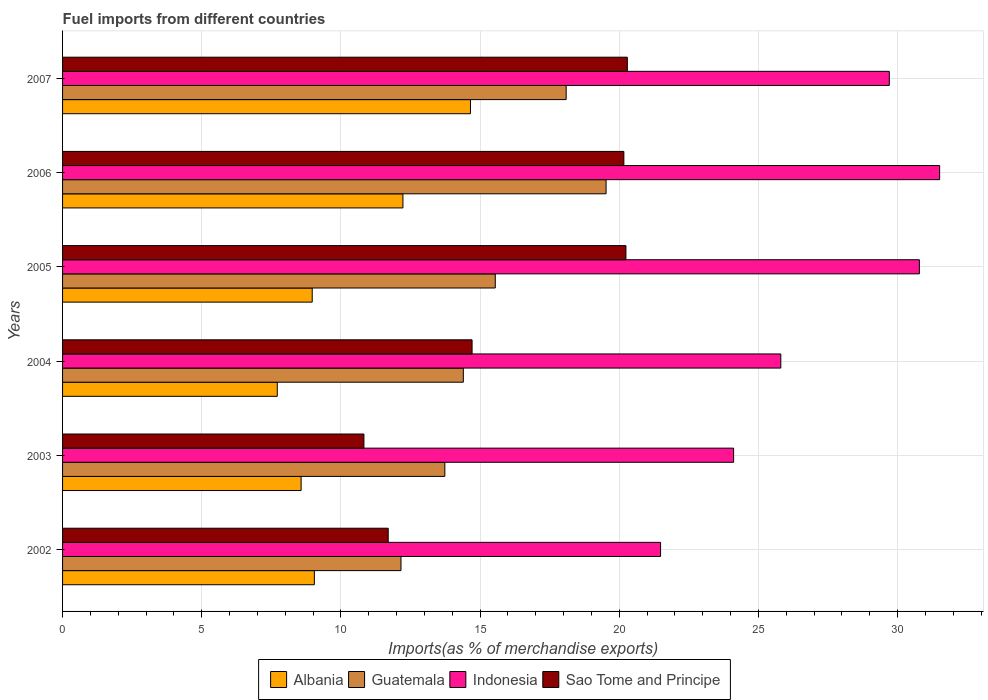How many different coloured bars are there?
Ensure brevity in your answer.  4. How many groups of bars are there?
Your response must be concise. 6. What is the label of the 6th group of bars from the top?
Offer a terse response. 2002. In how many cases, is the number of bars for a given year not equal to the number of legend labels?
Keep it short and to the point. 0. What is the percentage of imports to different countries in Indonesia in 2007?
Keep it short and to the point. 29.7. Across all years, what is the maximum percentage of imports to different countries in Albania?
Your response must be concise. 14.66. Across all years, what is the minimum percentage of imports to different countries in Guatemala?
Your answer should be very brief. 12.16. In which year was the percentage of imports to different countries in Indonesia maximum?
Provide a succinct answer. 2006. In which year was the percentage of imports to different countries in Sao Tome and Principe minimum?
Make the answer very short. 2003. What is the total percentage of imports to different countries in Guatemala in the graph?
Ensure brevity in your answer.  93.46. What is the difference between the percentage of imports to different countries in Guatemala in 2003 and that in 2007?
Ensure brevity in your answer.  -4.36. What is the difference between the percentage of imports to different countries in Sao Tome and Principe in 2005 and the percentage of imports to different countries in Albania in 2003?
Your answer should be compact. 11.67. What is the average percentage of imports to different countries in Albania per year?
Your answer should be very brief. 10.2. In the year 2002, what is the difference between the percentage of imports to different countries in Albania and percentage of imports to different countries in Sao Tome and Principe?
Your answer should be very brief. -2.65. What is the ratio of the percentage of imports to different countries in Guatemala in 2002 to that in 2003?
Provide a succinct answer. 0.89. Is the percentage of imports to different countries in Indonesia in 2002 less than that in 2005?
Keep it short and to the point. Yes. What is the difference between the highest and the second highest percentage of imports to different countries in Guatemala?
Your response must be concise. 1.43. What is the difference between the highest and the lowest percentage of imports to different countries in Albania?
Provide a succinct answer. 6.94. In how many years, is the percentage of imports to different countries in Guatemala greater than the average percentage of imports to different countries in Guatemala taken over all years?
Your response must be concise. 2. Is the sum of the percentage of imports to different countries in Albania in 2004 and 2005 greater than the maximum percentage of imports to different countries in Guatemala across all years?
Offer a very short reply. No. Is it the case that in every year, the sum of the percentage of imports to different countries in Sao Tome and Principe and percentage of imports to different countries in Guatemala is greater than the sum of percentage of imports to different countries in Indonesia and percentage of imports to different countries in Albania?
Ensure brevity in your answer.  No. What does the 1st bar from the top in 2002 represents?
Ensure brevity in your answer.  Sao Tome and Principe. What does the 1st bar from the bottom in 2007 represents?
Give a very brief answer. Albania. Is it the case that in every year, the sum of the percentage of imports to different countries in Sao Tome and Principe and percentage of imports to different countries in Indonesia is greater than the percentage of imports to different countries in Albania?
Make the answer very short. Yes. How many bars are there?
Keep it short and to the point. 24. How many years are there in the graph?
Offer a very short reply. 6. Are the values on the major ticks of X-axis written in scientific E-notation?
Offer a very short reply. No. Does the graph contain grids?
Provide a succinct answer. Yes. How many legend labels are there?
Your response must be concise. 4. What is the title of the graph?
Offer a terse response. Fuel imports from different countries. Does "Tunisia" appear as one of the legend labels in the graph?
Ensure brevity in your answer.  No. What is the label or title of the X-axis?
Make the answer very short. Imports(as % of merchandise exports). What is the label or title of the Y-axis?
Provide a short and direct response. Years. What is the Imports(as % of merchandise exports) in Albania in 2002?
Offer a terse response. 9.05. What is the Imports(as % of merchandise exports) of Guatemala in 2002?
Provide a succinct answer. 12.16. What is the Imports(as % of merchandise exports) of Indonesia in 2002?
Your response must be concise. 21.48. What is the Imports(as % of merchandise exports) in Sao Tome and Principe in 2002?
Make the answer very short. 11.7. What is the Imports(as % of merchandise exports) in Albania in 2003?
Provide a succinct answer. 8.57. What is the Imports(as % of merchandise exports) in Guatemala in 2003?
Offer a terse response. 13.73. What is the Imports(as % of merchandise exports) in Indonesia in 2003?
Ensure brevity in your answer.  24.11. What is the Imports(as % of merchandise exports) of Sao Tome and Principe in 2003?
Your answer should be very brief. 10.83. What is the Imports(as % of merchandise exports) in Albania in 2004?
Your answer should be very brief. 7.71. What is the Imports(as % of merchandise exports) of Guatemala in 2004?
Offer a very short reply. 14.4. What is the Imports(as % of merchandise exports) in Indonesia in 2004?
Ensure brevity in your answer.  25.8. What is the Imports(as % of merchandise exports) in Sao Tome and Principe in 2004?
Give a very brief answer. 14.71. What is the Imports(as % of merchandise exports) of Albania in 2005?
Ensure brevity in your answer.  8.97. What is the Imports(as % of merchandise exports) of Guatemala in 2005?
Ensure brevity in your answer.  15.55. What is the Imports(as % of merchandise exports) of Indonesia in 2005?
Your response must be concise. 30.78. What is the Imports(as % of merchandise exports) of Sao Tome and Principe in 2005?
Give a very brief answer. 20.24. What is the Imports(as % of merchandise exports) of Albania in 2006?
Provide a succinct answer. 12.23. What is the Imports(as % of merchandise exports) in Guatemala in 2006?
Give a very brief answer. 19.53. What is the Imports(as % of merchandise exports) of Indonesia in 2006?
Keep it short and to the point. 31.51. What is the Imports(as % of merchandise exports) of Sao Tome and Principe in 2006?
Your response must be concise. 20.17. What is the Imports(as % of merchandise exports) of Albania in 2007?
Ensure brevity in your answer.  14.66. What is the Imports(as % of merchandise exports) in Guatemala in 2007?
Give a very brief answer. 18.09. What is the Imports(as % of merchandise exports) of Indonesia in 2007?
Offer a terse response. 29.7. What is the Imports(as % of merchandise exports) of Sao Tome and Principe in 2007?
Your answer should be compact. 20.29. Across all years, what is the maximum Imports(as % of merchandise exports) in Albania?
Give a very brief answer. 14.66. Across all years, what is the maximum Imports(as % of merchandise exports) in Guatemala?
Your answer should be compact. 19.53. Across all years, what is the maximum Imports(as % of merchandise exports) of Indonesia?
Your response must be concise. 31.51. Across all years, what is the maximum Imports(as % of merchandise exports) in Sao Tome and Principe?
Your answer should be very brief. 20.29. Across all years, what is the minimum Imports(as % of merchandise exports) in Albania?
Your answer should be very brief. 7.71. Across all years, what is the minimum Imports(as % of merchandise exports) of Guatemala?
Keep it short and to the point. 12.16. Across all years, what is the minimum Imports(as % of merchandise exports) in Indonesia?
Your answer should be very brief. 21.48. Across all years, what is the minimum Imports(as % of merchandise exports) in Sao Tome and Principe?
Offer a very short reply. 10.83. What is the total Imports(as % of merchandise exports) of Albania in the graph?
Offer a very short reply. 61.18. What is the total Imports(as % of merchandise exports) of Guatemala in the graph?
Offer a terse response. 93.46. What is the total Imports(as % of merchandise exports) in Indonesia in the graph?
Offer a very short reply. 163.4. What is the total Imports(as % of merchandise exports) in Sao Tome and Principe in the graph?
Provide a short and direct response. 97.94. What is the difference between the Imports(as % of merchandise exports) of Albania in 2002 and that in 2003?
Provide a succinct answer. 0.48. What is the difference between the Imports(as % of merchandise exports) of Guatemala in 2002 and that in 2003?
Offer a very short reply. -1.58. What is the difference between the Imports(as % of merchandise exports) of Indonesia in 2002 and that in 2003?
Your response must be concise. -2.62. What is the difference between the Imports(as % of merchandise exports) of Sao Tome and Principe in 2002 and that in 2003?
Give a very brief answer. 0.87. What is the difference between the Imports(as % of merchandise exports) of Albania in 2002 and that in 2004?
Give a very brief answer. 1.33. What is the difference between the Imports(as % of merchandise exports) of Guatemala in 2002 and that in 2004?
Provide a succinct answer. -2.24. What is the difference between the Imports(as % of merchandise exports) in Indonesia in 2002 and that in 2004?
Make the answer very short. -4.32. What is the difference between the Imports(as % of merchandise exports) in Sao Tome and Principe in 2002 and that in 2004?
Your response must be concise. -3.01. What is the difference between the Imports(as % of merchandise exports) of Albania in 2002 and that in 2005?
Your answer should be compact. 0.08. What is the difference between the Imports(as % of merchandise exports) in Guatemala in 2002 and that in 2005?
Provide a short and direct response. -3.39. What is the difference between the Imports(as % of merchandise exports) of Indonesia in 2002 and that in 2005?
Your response must be concise. -9.3. What is the difference between the Imports(as % of merchandise exports) of Sao Tome and Principe in 2002 and that in 2005?
Ensure brevity in your answer.  -8.54. What is the difference between the Imports(as % of merchandise exports) in Albania in 2002 and that in 2006?
Offer a terse response. -3.18. What is the difference between the Imports(as % of merchandise exports) in Guatemala in 2002 and that in 2006?
Keep it short and to the point. -7.37. What is the difference between the Imports(as % of merchandise exports) of Indonesia in 2002 and that in 2006?
Make the answer very short. -10.03. What is the difference between the Imports(as % of merchandise exports) in Sao Tome and Principe in 2002 and that in 2006?
Your answer should be compact. -8.47. What is the difference between the Imports(as % of merchandise exports) of Albania in 2002 and that in 2007?
Provide a succinct answer. -5.61. What is the difference between the Imports(as % of merchandise exports) of Guatemala in 2002 and that in 2007?
Your answer should be compact. -5.93. What is the difference between the Imports(as % of merchandise exports) of Indonesia in 2002 and that in 2007?
Provide a succinct answer. -8.22. What is the difference between the Imports(as % of merchandise exports) of Sao Tome and Principe in 2002 and that in 2007?
Your answer should be compact. -8.59. What is the difference between the Imports(as % of merchandise exports) in Albania in 2003 and that in 2004?
Ensure brevity in your answer.  0.86. What is the difference between the Imports(as % of merchandise exports) in Guatemala in 2003 and that in 2004?
Your answer should be very brief. -0.66. What is the difference between the Imports(as % of merchandise exports) of Indonesia in 2003 and that in 2004?
Provide a short and direct response. -1.7. What is the difference between the Imports(as % of merchandise exports) in Sao Tome and Principe in 2003 and that in 2004?
Provide a succinct answer. -3.89. What is the difference between the Imports(as % of merchandise exports) in Albania in 2003 and that in 2005?
Your answer should be very brief. -0.4. What is the difference between the Imports(as % of merchandise exports) in Guatemala in 2003 and that in 2005?
Your answer should be compact. -1.81. What is the difference between the Imports(as % of merchandise exports) in Indonesia in 2003 and that in 2005?
Offer a terse response. -6.67. What is the difference between the Imports(as % of merchandise exports) in Sao Tome and Principe in 2003 and that in 2005?
Make the answer very short. -9.41. What is the difference between the Imports(as % of merchandise exports) of Albania in 2003 and that in 2006?
Provide a succinct answer. -3.66. What is the difference between the Imports(as % of merchandise exports) in Guatemala in 2003 and that in 2006?
Your answer should be compact. -5.79. What is the difference between the Imports(as % of merchandise exports) of Indonesia in 2003 and that in 2006?
Ensure brevity in your answer.  -7.4. What is the difference between the Imports(as % of merchandise exports) in Sao Tome and Principe in 2003 and that in 2006?
Offer a terse response. -9.34. What is the difference between the Imports(as % of merchandise exports) of Albania in 2003 and that in 2007?
Your answer should be compact. -6.08. What is the difference between the Imports(as % of merchandise exports) in Guatemala in 2003 and that in 2007?
Provide a succinct answer. -4.36. What is the difference between the Imports(as % of merchandise exports) of Indonesia in 2003 and that in 2007?
Offer a very short reply. -5.59. What is the difference between the Imports(as % of merchandise exports) of Sao Tome and Principe in 2003 and that in 2007?
Offer a very short reply. -9.46. What is the difference between the Imports(as % of merchandise exports) in Albania in 2004 and that in 2005?
Provide a short and direct response. -1.25. What is the difference between the Imports(as % of merchandise exports) in Guatemala in 2004 and that in 2005?
Ensure brevity in your answer.  -1.15. What is the difference between the Imports(as % of merchandise exports) of Indonesia in 2004 and that in 2005?
Give a very brief answer. -4.98. What is the difference between the Imports(as % of merchandise exports) in Sao Tome and Principe in 2004 and that in 2005?
Your response must be concise. -5.53. What is the difference between the Imports(as % of merchandise exports) of Albania in 2004 and that in 2006?
Your response must be concise. -4.51. What is the difference between the Imports(as % of merchandise exports) of Guatemala in 2004 and that in 2006?
Ensure brevity in your answer.  -5.13. What is the difference between the Imports(as % of merchandise exports) of Indonesia in 2004 and that in 2006?
Your answer should be very brief. -5.71. What is the difference between the Imports(as % of merchandise exports) in Sao Tome and Principe in 2004 and that in 2006?
Give a very brief answer. -5.45. What is the difference between the Imports(as % of merchandise exports) in Albania in 2004 and that in 2007?
Offer a terse response. -6.94. What is the difference between the Imports(as % of merchandise exports) of Guatemala in 2004 and that in 2007?
Your answer should be very brief. -3.69. What is the difference between the Imports(as % of merchandise exports) in Indonesia in 2004 and that in 2007?
Offer a terse response. -3.9. What is the difference between the Imports(as % of merchandise exports) in Sao Tome and Principe in 2004 and that in 2007?
Offer a terse response. -5.58. What is the difference between the Imports(as % of merchandise exports) of Albania in 2005 and that in 2006?
Your answer should be very brief. -3.26. What is the difference between the Imports(as % of merchandise exports) of Guatemala in 2005 and that in 2006?
Your answer should be compact. -3.98. What is the difference between the Imports(as % of merchandise exports) of Indonesia in 2005 and that in 2006?
Your answer should be very brief. -0.73. What is the difference between the Imports(as % of merchandise exports) in Sao Tome and Principe in 2005 and that in 2006?
Your response must be concise. 0.07. What is the difference between the Imports(as % of merchandise exports) of Albania in 2005 and that in 2007?
Keep it short and to the point. -5.69. What is the difference between the Imports(as % of merchandise exports) in Guatemala in 2005 and that in 2007?
Offer a terse response. -2.55. What is the difference between the Imports(as % of merchandise exports) in Sao Tome and Principe in 2005 and that in 2007?
Ensure brevity in your answer.  -0.05. What is the difference between the Imports(as % of merchandise exports) in Albania in 2006 and that in 2007?
Provide a succinct answer. -2.43. What is the difference between the Imports(as % of merchandise exports) in Guatemala in 2006 and that in 2007?
Your response must be concise. 1.43. What is the difference between the Imports(as % of merchandise exports) of Indonesia in 2006 and that in 2007?
Your response must be concise. 1.81. What is the difference between the Imports(as % of merchandise exports) of Sao Tome and Principe in 2006 and that in 2007?
Your response must be concise. -0.12. What is the difference between the Imports(as % of merchandise exports) of Albania in 2002 and the Imports(as % of merchandise exports) of Guatemala in 2003?
Ensure brevity in your answer.  -4.69. What is the difference between the Imports(as % of merchandise exports) of Albania in 2002 and the Imports(as % of merchandise exports) of Indonesia in 2003?
Offer a terse response. -15.06. What is the difference between the Imports(as % of merchandise exports) in Albania in 2002 and the Imports(as % of merchandise exports) in Sao Tome and Principe in 2003?
Ensure brevity in your answer.  -1.78. What is the difference between the Imports(as % of merchandise exports) in Guatemala in 2002 and the Imports(as % of merchandise exports) in Indonesia in 2003?
Your answer should be compact. -11.95. What is the difference between the Imports(as % of merchandise exports) in Guatemala in 2002 and the Imports(as % of merchandise exports) in Sao Tome and Principe in 2003?
Your answer should be very brief. 1.33. What is the difference between the Imports(as % of merchandise exports) of Indonesia in 2002 and the Imports(as % of merchandise exports) of Sao Tome and Principe in 2003?
Provide a succinct answer. 10.66. What is the difference between the Imports(as % of merchandise exports) in Albania in 2002 and the Imports(as % of merchandise exports) in Guatemala in 2004?
Provide a succinct answer. -5.35. What is the difference between the Imports(as % of merchandise exports) in Albania in 2002 and the Imports(as % of merchandise exports) in Indonesia in 2004?
Ensure brevity in your answer.  -16.76. What is the difference between the Imports(as % of merchandise exports) in Albania in 2002 and the Imports(as % of merchandise exports) in Sao Tome and Principe in 2004?
Ensure brevity in your answer.  -5.67. What is the difference between the Imports(as % of merchandise exports) in Guatemala in 2002 and the Imports(as % of merchandise exports) in Indonesia in 2004?
Your response must be concise. -13.65. What is the difference between the Imports(as % of merchandise exports) of Guatemala in 2002 and the Imports(as % of merchandise exports) of Sao Tome and Principe in 2004?
Give a very brief answer. -2.55. What is the difference between the Imports(as % of merchandise exports) of Indonesia in 2002 and the Imports(as % of merchandise exports) of Sao Tome and Principe in 2004?
Keep it short and to the point. 6.77. What is the difference between the Imports(as % of merchandise exports) in Albania in 2002 and the Imports(as % of merchandise exports) in Guatemala in 2005?
Keep it short and to the point. -6.5. What is the difference between the Imports(as % of merchandise exports) in Albania in 2002 and the Imports(as % of merchandise exports) in Indonesia in 2005?
Provide a short and direct response. -21.74. What is the difference between the Imports(as % of merchandise exports) of Albania in 2002 and the Imports(as % of merchandise exports) of Sao Tome and Principe in 2005?
Ensure brevity in your answer.  -11.19. What is the difference between the Imports(as % of merchandise exports) in Guatemala in 2002 and the Imports(as % of merchandise exports) in Indonesia in 2005?
Ensure brevity in your answer.  -18.62. What is the difference between the Imports(as % of merchandise exports) of Guatemala in 2002 and the Imports(as % of merchandise exports) of Sao Tome and Principe in 2005?
Your response must be concise. -8.08. What is the difference between the Imports(as % of merchandise exports) of Indonesia in 2002 and the Imports(as % of merchandise exports) of Sao Tome and Principe in 2005?
Keep it short and to the point. 1.24. What is the difference between the Imports(as % of merchandise exports) in Albania in 2002 and the Imports(as % of merchandise exports) in Guatemala in 2006?
Provide a short and direct response. -10.48. What is the difference between the Imports(as % of merchandise exports) of Albania in 2002 and the Imports(as % of merchandise exports) of Indonesia in 2006?
Offer a very short reply. -22.46. What is the difference between the Imports(as % of merchandise exports) of Albania in 2002 and the Imports(as % of merchandise exports) of Sao Tome and Principe in 2006?
Provide a succinct answer. -11.12. What is the difference between the Imports(as % of merchandise exports) in Guatemala in 2002 and the Imports(as % of merchandise exports) in Indonesia in 2006?
Ensure brevity in your answer.  -19.35. What is the difference between the Imports(as % of merchandise exports) in Guatemala in 2002 and the Imports(as % of merchandise exports) in Sao Tome and Principe in 2006?
Provide a succinct answer. -8.01. What is the difference between the Imports(as % of merchandise exports) in Indonesia in 2002 and the Imports(as % of merchandise exports) in Sao Tome and Principe in 2006?
Make the answer very short. 1.32. What is the difference between the Imports(as % of merchandise exports) of Albania in 2002 and the Imports(as % of merchandise exports) of Guatemala in 2007?
Your answer should be very brief. -9.05. What is the difference between the Imports(as % of merchandise exports) in Albania in 2002 and the Imports(as % of merchandise exports) in Indonesia in 2007?
Your response must be concise. -20.66. What is the difference between the Imports(as % of merchandise exports) in Albania in 2002 and the Imports(as % of merchandise exports) in Sao Tome and Principe in 2007?
Make the answer very short. -11.24. What is the difference between the Imports(as % of merchandise exports) in Guatemala in 2002 and the Imports(as % of merchandise exports) in Indonesia in 2007?
Make the answer very short. -17.54. What is the difference between the Imports(as % of merchandise exports) of Guatemala in 2002 and the Imports(as % of merchandise exports) of Sao Tome and Principe in 2007?
Your answer should be very brief. -8.13. What is the difference between the Imports(as % of merchandise exports) in Indonesia in 2002 and the Imports(as % of merchandise exports) in Sao Tome and Principe in 2007?
Ensure brevity in your answer.  1.19. What is the difference between the Imports(as % of merchandise exports) of Albania in 2003 and the Imports(as % of merchandise exports) of Guatemala in 2004?
Keep it short and to the point. -5.83. What is the difference between the Imports(as % of merchandise exports) in Albania in 2003 and the Imports(as % of merchandise exports) in Indonesia in 2004?
Your response must be concise. -17.23. What is the difference between the Imports(as % of merchandise exports) of Albania in 2003 and the Imports(as % of merchandise exports) of Sao Tome and Principe in 2004?
Offer a very short reply. -6.14. What is the difference between the Imports(as % of merchandise exports) of Guatemala in 2003 and the Imports(as % of merchandise exports) of Indonesia in 2004?
Your answer should be very brief. -12.07. What is the difference between the Imports(as % of merchandise exports) in Guatemala in 2003 and the Imports(as % of merchandise exports) in Sao Tome and Principe in 2004?
Your answer should be compact. -0.98. What is the difference between the Imports(as % of merchandise exports) of Indonesia in 2003 and the Imports(as % of merchandise exports) of Sao Tome and Principe in 2004?
Provide a short and direct response. 9.4. What is the difference between the Imports(as % of merchandise exports) in Albania in 2003 and the Imports(as % of merchandise exports) in Guatemala in 2005?
Ensure brevity in your answer.  -6.98. What is the difference between the Imports(as % of merchandise exports) in Albania in 2003 and the Imports(as % of merchandise exports) in Indonesia in 2005?
Your response must be concise. -22.21. What is the difference between the Imports(as % of merchandise exports) of Albania in 2003 and the Imports(as % of merchandise exports) of Sao Tome and Principe in 2005?
Offer a terse response. -11.67. What is the difference between the Imports(as % of merchandise exports) of Guatemala in 2003 and the Imports(as % of merchandise exports) of Indonesia in 2005?
Provide a succinct answer. -17.05. What is the difference between the Imports(as % of merchandise exports) in Guatemala in 2003 and the Imports(as % of merchandise exports) in Sao Tome and Principe in 2005?
Your answer should be compact. -6.51. What is the difference between the Imports(as % of merchandise exports) of Indonesia in 2003 and the Imports(as % of merchandise exports) of Sao Tome and Principe in 2005?
Provide a short and direct response. 3.87. What is the difference between the Imports(as % of merchandise exports) in Albania in 2003 and the Imports(as % of merchandise exports) in Guatemala in 2006?
Provide a succinct answer. -10.96. What is the difference between the Imports(as % of merchandise exports) in Albania in 2003 and the Imports(as % of merchandise exports) in Indonesia in 2006?
Ensure brevity in your answer.  -22.94. What is the difference between the Imports(as % of merchandise exports) in Albania in 2003 and the Imports(as % of merchandise exports) in Sao Tome and Principe in 2006?
Provide a short and direct response. -11.6. What is the difference between the Imports(as % of merchandise exports) in Guatemala in 2003 and the Imports(as % of merchandise exports) in Indonesia in 2006?
Your response must be concise. -17.78. What is the difference between the Imports(as % of merchandise exports) of Guatemala in 2003 and the Imports(as % of merchandise exports) of Sao Tome and Principe in 2006?
Keep it short and to the point. -6.43. What is the difference between the Imports(as % of merchandise exports) in Indonesia in 2003 and the Imports(as % of merchandise exports) in Sao Tome and Principe in 2006?
Ensure brevity in your answer.  3.94. What is the difference between the Imports(as % of merchandise exports) in Albania in 2003 and the Imports(as % of merchandise exports) in Guatemala in 2007?
Your answer should be very brief. -9.52. What is the difference between the Imports(as % of merchandise exports) of Albania in 2003 and the Imports(as % of merchandise exports) of Indonesia in 2007?
Keep it short and to the point. -21.13. What is the difference between the Imports(as % of merchandise exports) of Albania in 2003 and the Imports(as % of merchandise exports) of Sao Tome and Principe in 2007?
Your answer should be very brief. -11.72. What is the difference between the Imports(as % of merchandise exports) in Guatemala in 2003 and the Imports(as % of merchandise exports) in Indonesia in 2007?
Your response must be concise. -15.97. What is the difference between the Imports(as % of merchandise exports) in Guatemala in 2003 and the Imports(as % of merchandise exports) in Sao Tome and Principe in 2007?
Your answer should be very brief. -6.56. What is the difference between the Imports(as % of merchandise exports) of Indonesia in 2003 and the Imports(as % of merchandise exports) of Sao Tome and Principe in 2007?
Your answer should be compact. 3.82. What is the difference between the Imports(as % of merchandise exports) of Albania in 2004 and the Imports(as % of merchandise exports) of Guatemala in 2005?
Your answer should be very brief. -7.83. What is the difference between the Imports(as % of merchandise exports) of Albania in 2004 and the Imports(as % of merchandise exports) of Indonesia in 2005?
Offer a very short reply. -23.07. What is the difference between the Imports(as % of merchandise exports) in Albania in 2004 and the Imports(as % of merchandise exports) in Sao Tome and Principe in 2005?
Offer a very short reply. -12.53. What is the difference between the Imports(as % of merchandise exports) of Guatemala in 2004 and the Imports(as % of merchandise exports) of Indonesia in 2005?
Offer a terse response. -16.38. What is the difference between the Imports(as % of merchandise exports) in Guatemala in 2004 and the Imports(as % of merchandise exports) in Sao Tome and Principe in 2005?
Your answer should be compact. -5.84. What is the difference between the Imports(as % of merchandise exports) in Indonesia in 2004 and the Imports(as % of merchandise exports) in Sao Tome and Principe in 2005?
Offer a terse response. 5.56. What is the difference between the Imports(as % of merchandise exports) of Albania in 2004 and the Imports(as % of merchandise exports) of Guatemala in 2006?
Your answer should be compact. -11.81. What is the difference between the Imports(as % of merchandise exports) of Albania in 2004 and the Imports(as % of merchandise exports) of Indonesia in 2006?
Give a very brief answer. -23.8. What is the difference between the Imports(as % of merchandise exports) in Albania in 2004 and the Imports(as % of merchandise exports) in Sao Tome and Principe in 2006?
Provide a succinct answer. -12.45. What is the difference between the Imports(as % of merchandise exports) of Guatemala in 2004 and the Imports(as % of merchandise exports) of Indonesia in 2006?
Your answer should be very brief. -17.11. What is the difference between the Imports(as % of merchandise exports) in Guatemala in 2004 and the Imports(as % of merchandise exports) in Sao Tome and Principe in 2006?
Give a very brief answer. -5.77. What is the difference between the Imports(as % of merchandise exports) in Indonesia in 2004 and the Imports(as % of merchandise exports) in Sao Tome and Principe in 2006?
Ensure brevity in your answer.  5.64. What is the difference between the Imports(as % of merchandise exports) of Albania in 2004 and the Imports(as % of merchandise exports) of Guatemala in 2007?
Make the answer very short. -10.38. What is the difference between the Imports(as % of merchandise exports) of Albania in 2004 and the Imports(as % of merchandise exports) of Indonesia in 2007?
Provide a short and direct response. -21.99. What is the difference between the Imports(as % of merchandise exports) of Albania in 2004 and the Imports(as % of merchandise exports) of Sao Tome and Principe in 2007?
Give a very brief answer. -12.58. What is the difference between the Imports(as % of merchandise exports) in Guatemala in 2004 and the Imports(as % of merchandise exports) in Indonesia in 2007?
Offer a terse response. -15.3. What is the difference between the Imports(as % of merchandise exports) in Guatemala in 2004 and the Imports(as % of merchandise exports) in Sao Tome and Principe in 2007?
Make the answer very short. -5.89. What is the difference between the Imports(as % of merchandise exports) of Indonesia in 2004 and the Imports(as % of merchandise exports) of Sao Tome and Principe in 2007?
Offer a terse response. 5.51. What is the difference between the Imports(as % of merchandise exports) of Albania in 2005 and the Imports(as % of merchandise exports) of Guatemala in 2006?
Give a very brief answer. -10.56. What is the difference between the Imports(as % of merchandise exports) of Albania in 2005 and the Imports(as % of merchandise exports) of Indonesia in 2006?
Offer a terse response. -22.54. What is the difference between the Imports(as % of merchandise exports) of Albania in 2005 and the Imports(as % of merchandise exports) of Sao Tome and Principe in 2006?
Your response must be concise. -11.2. What is the difference between the Imports(as % of merchandise exports) in Guatemala in 2005 and the Imports(as % of merchandise exports) in Indonesia in 2006?
Give a very brief answer. -15.96. What is the difference between the Imports(as % of merchandise exports) of Guatemala in 2005 and the Imports(as % of merchandise exports) of Sao Tome and Principe in 2006?
Your answer should be very brief. -4.62. What is the difference between the Imports(as % of merchandise exports) in Indonesia in 2005 and the Imports(as % of merchandise exports) in Sao Tome and Principe in 2006?
Your answer should be very brief. 10.62. What is the difference between the Imports(as % of merchandise exports) in Albania in 2005 and the Imports(as % of merchandise exports) in Guatemala in 2007?
Provide a short and direct response. -9.12. What is the difference between the Imports(as % of merchandise exports) in Albania in 2005 and the Imports(as % of merchandise exports) in Indonesia in 2007?
Your answer should be compact. -20.73. What is the difference between the Imports(as % of merchandise exports) in Albania in 2005 and the Imports(as % of merchandise exports) in Sao Tome and Principe in 2007?
Give a very brief answer. -11.32. What is the difference between the Imports(as % of merchandise exports) in Guatemala in 2005 and the Imports(as % of merchandise exports) in Indonesia in 2007?
Provide a short and direct response. -14.16. What is the difference between the Imports(as % of merchandise exports) of Guatemala in 2005 and the Imports(as % of merchandise exports) of Sao Tome and Principe in 2007?
Provide a succinct answer. -4.74. What is the difference between the Imports(as % of merchandise exports) in Indonesia in 2005 and the Imports(as % of merchandise exports) in Sao Tome and Principe in 2007?
Offer a terse response. 10.49. What is the difference between the Imports(as % of merchandise exports) of Albania in 2006 and the Imports(as % of merchandise exports) of Guatemala in 2007?
Provide a succinct answer. -5.86. What is the difference between the Imports(as % of merchandise exports) of Albania in 2006 and the Imports(as % of merchandise exports) of Indonesia in 2007?
Make the answer very short. -17.47. What is the difference between the Imports(as % of merchandise exports) of Albania in 2006 and the Imports(as % of merchandise exports) of Sao Tome and Principe in 2007?
Your response must be concise. -8.06. What is the difference between the Imports(as % of merchandise exports) in Guatemala in 2006 and the Imports(as % of merchandise exports) in Indonesia in 2007?
Keep it short and to the point. -10.18. What is the difference between the Imports(as % of merchandise exports) of Guatemala in 2006 and the Imports(as % of merchandise exports) of Sao Tome and Principe in 2007?
Your answer should be compact. -0.76. What is the difference between the Imports(as % of merchandise exports) in Indonesia in 2006 and the Imports(as % of merchandise exports) in Sao Tome and Principe in 2007?
Make the answer very short. 11.22. What is the average Imports(as % of merchandise exports) in Albania per year?
Provide a short and direct response. 10.2. What is the average Imports(as % of merchandise exports) in Guatemala per year?
Give a very brief answer. 15.58. What is the average Imports(as % of merchandise exports) of Indonesia per year?
Offer a very short reply. 27.23. What is the average Imports(as % of merchandise exports) of Sao Tome and Principe per year?
Your answer should be compact. 16.32. In the year 2002, what is the difference between the Imports(as % of merchandise exports) in Albania and Imports(as % of merchandise exports) in Guatemala?
Offer a terse response. -3.11. In the year 2002, what is the difference between the Imports(as % of merchandise exports) of Albania and Imports(as % of merchandise exports) of Indonesia?
Provide a succinct answer. -12.44. In the year 2002, what is the difference between the Imports(as % of merchandise exports) of Albania and Imports(as % of merchandise exports) of Sao Tome and Principe?
Offer a very short reply. -2.65. In the year 2002, what is the difference between the Imports(as % of merchandise exports) in Guatemala and Imports(as % of merchandise exports) in Indonesia?
Keep it short and to the point. -9.33. In the year 2002, what is the difference between the Imports(as % of merchandise exports) in Guatemala and Imports(as % of merchandise exports) in Sao Tome and Principe?
Give a very brief answer. 0.46. In the year 2002, what is the difference between the Imports(as % of merchandise exports) of Indonesia and Imports(as % of merchandise exports) of Sao Tome and Principe?
Keep it short and to the point. 9.79. In the year 2003, what is the difference between the Imports(as % of merchandise exports) of Albania and Imports(as % of merchandise exports) of Guatemala?
Offer a terse response. -5.16. In the year 2003, what is the difference between the Imports(as % of merchandise exports) in Albania and Imports(as % of merchandise exports) in Indonesia?
Offer a very short reply. -15.54. In the year 2003, what is the difference between the Imports(as % of merchandise exports) in Albania and Imports(as % of merchandise exports) in Sao Tome and Principe?
Provide a succinct answer. -2.26. In the year 2003, what is the difference between the Imports(as % of merchandise exports) in Guatemala and Imports(as % of merchandise exports) in Indonesia?
Your answer should be compact. -10.37. In the year 2003, what is the difference between the Imports(as % of merchandise exports) of Guatemala and Imports(as % of merchandise exports) of Sao Tome and Principe?
Your response must be concise. 2.91. In the year 2003, what is the difference between the Imports(as % of merchandise exports) of Indonesia and Imports(as % of merchandise exports) of Sao Tome and Principe?
Your answer should be compact. 13.28. In the year 2004, what is the difference between the Imports(as % of merchandise exports) of Albania and Imports(as % of merchandise exports) of Guatemala?
Offer a very short reply. -6.68. In the year 2004, what is the difference between the Imports(as % of merchandise exports) in Albania and Imports(as % of merchandise exports) in Indonesia?
Your response must be concise. -18.09. In the year 2004, what is the difference between the Imports(as % of merchandise exports) in Albania and Imports(as % of merchandise exports) in Sao Tome and Principe?
Make the answer very short. -7. In the year 2004, what is the difference between the Imports(as % of merchandise exports) in Guatemala and Imports(as % of merchandise exports) in Indonesia?
Provide a short and direct response. -11.41. In the year 2004, what is the difference between the Imports(as % of merchandise exports) of Guatemala and Imports(as % of merchandise exports) of Sao Tome and Principe?
Offer a very short reply. -0.31. In the year 2004, what is the difference between the Imports(as % of merchandise exports) of Indonesia and Imports(as % of merchandise exports) of Sao Tome and Principe?
Ensure brevity in your answer.  11.09. In the year 2005, what is the difference between the Imports(as % of merchandise exports) of Albania and Imports(as % of merchandise exports) of Guatemala?
Your answer should be very brief. -6.58. In the year 2005, what is the difference between the Imports(as % of merchandise exports) of Albania and Imports(as % of merchandise exports) of Indonesia?
Offer a very short reply. -21.81. In the year 2005, what is the difference between the Imports(as % of merchandise exports) in Albania and Imports(as % of merchandise exports) in Sao Tome and Principe?
Provide a succinct answer. -11.27. In the year 2005, what is the difference between the Imports(as % of merchandise exports) of Guatemala and Imports(as % of merchandise exports) of Indonesia?
Ensure brevity in your answer.  -15.24. In the year 2005, what is the difference between the Imports(as % of merchandise exports) in Guatemala and Imports(as % of merchandise exports) in Sao Tome and Principe?
Offer a terse response. -4.69. In the year 2005, what is the difference between the Imports(as % of merchandise exports) in Indonesia and Imports(as % of merchandise exports) in Sao Tome and Principe?
Your answer should be very brief. 10.54. In the year 2006, what is the difference between the Imports(as % of merchandise exports) of Albania and Imports(as % of merchandise exports) of Guatemala?
Your answer should be compact. -7.3. In the year 2006, what is the difference between the Imports(as % of merchandise exports) of Albania and Imports(as % of merchandise exports) of Indonesia?
Your answer should be compact. -19.28. In the year 2006, what is the difference between the Imports(as % of merchandise exports) in Albania and Imports(as % of merchandise exports) in Sao Tome and Principe?
Your answer should be compact. -7.94. In the year 2006, what is the difference between the Imports(as % of merchandise exports) in Guatemala and Imports(as % of merchandise exports) in Indonesia?
Offer a terse response. -11.98. In the year 2006, what is the difference between the Imports(as % of merchandise exports) of Guatemala and Imports(as % of merchandise exports) of Sao Tome and Principe?
Keep it short and to the point. -0.64. In the year 2006, what is the difference between the Imports(as % of merchandise exports) in Indonesia and Imports(as % of merchandise exports) in Sao Tome and Principe?
Provide a short and direct response. 11.35. In the year 2007, what is the difference between the Imports(as % of merchandise exports) of Albania and Imports(as % of merchandise exports) of Guatemala?
Give a very brief answer. -3.44. In the year 2007, what is the difference between the Imports(as % of merchandise exports) in Albania and Imports(as % of merchandise exports) in Indonesia?
Make the answer very short. -15.05. In the year 2007, what is the difference between the Imports(as % of merchandise exports) in Albania and Imports(as % of merchandise exports) in Sao Tome and Principe?
Provide a succinct answer. -5.64. In the year 2007, what is the difference between the Imports(as % of merchandise exports) in Guatemala and Imports(as % of merchandise exports) in Indonesia?
Provide a succinct answer. -11.61. In the year 2007, what is the difference between the Imports(as % of merchandise exports) of Guatemala and Imports(as % of merchandise exports) of Sao Tome and Principe?
Offer a terse response. -2.2. In the year 2007, what is the difference between the Imports(as % of merchandise exports) of Indonesia and Imports(as % of merchandise exports) of Sao Tome and Principe?
Your answer should be very brief. 9.41. What is the ratio of the Imports(as % of merchandise exports) in Albania in 2002 to that in 2003?
Provide a succinct answer. 1.06. What is the ratio of the Imports(as % of merchandise exports) of Guatemala in 2002 to that in 2003?
Offer a terse response. 0.89. What is the ratio of the Imports(as % of merchandise exports) in Indonesia in 2002 to that in 2003?
Provide a short and direct response. 0.89. What is the ratio of the Imports(as % of merchandise exports) of Sao Tome and Principe in 2002 to that in 2003?
Make the answer very short. 1.08. What is the ratio of the Imports(as % of merchandise exports) of Albania in 2002 to that in 2004?
Your answer should be very brief. 1.17. What is the ratio of the Imports(as % of merchandise exports) in Guatemala in 2002 to that in 2004?
Provide a succinct answer. 0.84. What is the ratio of the Imports(as % of merchandise exports) of Indonesia in 2002 to that in 2004?
Your response must be concise. 0.83. What is the ratio of the Imports(as % of merchandise exports) of Sao Tome and Principe in 2002 to that in 2004?
Provide a short and direct response. 0.8. What is the ratio of the Imports(as % of merchandise exports) in Albania in 2002 to that in 2005?
Provide a succinct answer. 1.01. What is the ratio of the Imports(as % of merchandise exports) in Guatemala in 2002 to that in 2005?
Your answer should be compact. 0.78. What is the ratio of the Imports(as % of merchandise exports) in Indonesia in 2002 to that in 2005?
Keep it short and to the point. 0.7. What is the ratio of the Imports(as % of merchandise exports) of Sao Tome and Principe in 2002 to that in 2005?
Your response must be concise. 0.58. What is the ratio of the Imports(as % of merchandise exports) of Albania in 2002 to that in 2006?
Keep it short and to the point. 0.74. What is the ratio of the Imports(as % of merchandise exports) in Guatemala in 2002 to that in 2006?
Your answer should be compact. 0.62. What is the ratio of the Imports(as % of merchandise exports) in Indonesia in 2002 to that in 2006?
Offer a terse response. 0.68. What is the ratio of the Imports(as % of merchandise exports) of Sao Tome and Principe in 2002 to that in 2006?
Make the answer very short. 0.58. What is the ratio of the Imports(as % of merchandise exports) of Albania in 2002 to that in 2007?
Keep it short and to the point. 0.62. What is the ratio of the Imports(as % of merchandise exports) in Guatemala in 2002 to that in 2007?
Offer a terse response. 0.67. What is the ratio of the Imports(as % of merchandise exports) of Indonesia in 2002 to that in 2007?
Ensure brevity in your answer.  0.72. What is the ratio of the Imports(as % of merchandise exports) of Sao Tome and Principe in 2002 to that in 2007?
Provide a short and direct response. 0.58. What is the ratio of the Imports(as % of merchandise exports) in Albania in 2003 to that in 2004?
Offer a very short reply. 1.11. What is the ratio of the Imports(as % of merchandise exports) of Guatemala in 2003 to that in 2004?
Ensure brevity in your answer.  0.95. What is the ratio of the Imports(as % of merchandise exports) in Indonesia in 2003 to that in 2004?
Your response must be concise. 0.93. What is the ratio of the Imports(as % of merchandise exports) of Sao Tome and Principe in 2003 to that in 2004?
Provide a short and direct response. 0.74. What is the ratio of the Imports(as % of merchandise exports) of Albania in 2003 to that in 2005?
Ensure brevity in your answer.  0.96. What is the ratio of the Imports(as % of merchandise exports) of Guatemala in 2003 to that in 2005?
Give a very brief answer. 0.88. What is the ratio of the Imports(as % of merchandise exports) in Indonesia in 2003 to that in 2005?
Ensure brevity in your answer.  0.78. What is the ratio of the Imports(as % of merchandise exports) in Sao Tome and Principe in 2003 to that in 2005?
Give a very brief answer. 0.53. What is the ratio of the Imports(as % of merchandise exports) in Albania in 2003 to that in 2006?
Your response must be concise. 0.7. What is the ratio of the Imports(as % of merchandise exports) of Guatemala in 2003 to that in 2006?
Provide a succinct answer. 0.7. What is the ratio of the Imports(as % of merchandise exports) of Indonesia in 2003 to that in 2006?
Provide a short and direct response. 0.77. What is the ratio of the Imports(as % of merchandise exports) of Sao Tome and Principe in 2003 to that in 2006?
Keep it short and to the point. 0.54. What is the ratio of the Imports(as % of merchandise exports) of Albania in 2003 to that in 2007?
Ensure brevity in your answer.  0.58. What is the ratio of the Imports(as % of merchandise exports) of Guatemala in 2003 to that in 2007?
Provide a succinct answer. 0.76. What is the ratio of the Imports(as % of merchandise exports) in Indonesia in 2003 to that in 2007?
Make the answer very short. 0.81. What is the ratio of the Imports(as % of merchandise exports) of Sao Tome and Principe in 2003 to that in 2007?
Offer a very short reply. 0.53. What is the ratio of the Imports(as % of merchandise exports) in Albania in 2004 to that in 2005?
Your answer should be very brief. 0.86. What is the ratio of the Imports(as % of merchandise exports) in Guatemala in 2004 to that in 2005?
Provide a short and direct response. 0.93. What is the ratio of the Imports(as % of merchandise exports) of Indonesia in 2004 to that in 2005?
Ensure brevity in your answer.  0.84. What is the ratio of the Imports(as % of merchandise exports) of Sao Tome and Principe in 2004 to that in 2005?
Your response must be concise. 0.73. What is the ratio of the Imports(as % of merchandise exports) of Albania in 2004 to that in 2006?
Offer a terse response. 0.63. What is the ratio of the Imports(as % of merchandise exports) of Guatemala in 2004 to that in 2006?
Provide a succinct answer. 0.74. What is the ratio of the Imports(as % of merchandise exports) of Indonesia in 2004 to that in 2006?
Give a very brief answer. 0.82. What is the ratio of the Imports(as % of merchandise exports) in Sao Tome and Principe in 2004 to that in 2006?
Offer a very short reply. 0.73. What is the ratio of the Imports(as % of merchandise exports) in Albania in 2004 to that in 2007?
Provide a short and direct response. 0.53. What is the ratio of the Imports(as % of merchandise exports) in Guatemala in 2004 to that in 2007?
Keep it short and to the point. 0.8. What is the ratio of the Imports(as % of merchandise exports) of Indonesia in 2004 to that in 2007?
Offer a terse response. 0.87. What is the ratio of the Imports(as % of merchandise exports) of Sao Tome and Principe in 2004 to that in 2007?
Offer a terse response. 0.73. What is the ratio of the Imports(as % of merchandise exports) in Albania in 2005 to that in 2006?
Provide a short and direct response. 0.73. What is the ratio of the Imports(as % of merchandise exports) of Guatemala in 2005 to that in 2006?
Offer a terse response. 0.8. What is the ratio of the Imports(as % of merchandise exports) of Indonesia in 2005 to that in 2006?
Your response must be concise. 0.98. What is the ratio of the Imports(as % of merchandise exports) in Albania in 2005 to that in 2007?
Ensure brevity in your answer.  0.61. What is the ratio of the Imports(as % of merchandise exports) in Guatemala in 2005 to that in 2007?
Give a very brief answer. 0.86. What is the ratio of the Imports(as % of merchandise exports) in Indonesia in 2005 to that in 2007?
Provide a succinct answer. 1.04. What is the ratio of the Imports(as % of merchandise exports) of Sao Tome and Principe in 2005 to that in 2007?
Provide a succinct answer. 1. What is the ratio of the Imports(as % of merchandise exports) of Albania in 2006 to that in 2007?
Give a very brief answer. 0.83. What is the ratio of the Imports(as % of merchandise exports) in Guatemala in 2006 to that in 2007?
Make the answer very short. 1.08. What is the ratio of the Imports(as % of merchandise exports) in Indonesia in 2006 to that in 2007?
Provide a short and direct response. 1.06. What is the ratio of the Imports(as % of merchandise exports) in Sao Tome and Principe in 2006 to that in 2007?
Your response must be concise. 0.99. What is the difference between the highest and the second highest Imports(as % of merchandise exports) of Albania?
Keep it short and to the point. 2.43. What is the difference between the highest and the second highest Imports(as % of merchandise exports) of Guatemala?
Give a very brief answer. 1.43. What is the difference between the highest and the second highest Imports(as % of merchandise exports) of Indonesia?
Your response must be concise. 0.73. What is the difference between the highest and the second highest Imports(as % of merchandise exports) in Sao Tome and Principe?
Your answer should be compact. 0.05. What is the difference between the highest and the lowest Imports(as % of merchandise exports) in Albania?
Offer a terse response. 6.94. What is the difference between the highest and the lowest Imports(as % of merchandise exports) of Guatemala?
Your answer should be very brief. 7.37. What is the difference between the highest and the lowest Imports(as % of merchandise exports) of Indonesia?
Keep it short and to the point. 10.03. What is the difference between the highest and the lowest Imports(as % of merchandise exports) of Sao Tome and Principe?
Offer a terse response. 9.46. 